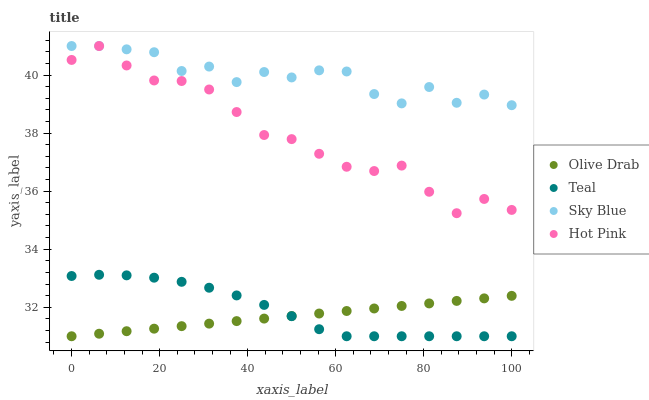Does Olive Drab have the minimum area under the curve?
Answer yes or no. Yes. Does Sky Blue have the maximum area under the curve?
Answer yes or no. Yes. Does Hot Pink have the minimum area under the curve?
Answer yes or no. No. Does Hot Pink have the maximum area under the curve?
Answer yes or no. No. Is Olive Drab the smoothest?
Answer yes or no. Yes. Is Sky Blue the roughest?
Answer yes or no. Yes. Is Hot Pink the smoothest?
Answer yes or no. No. Is Hot Pink the roughest?
Answer yes or no. No. Does Teal have the lowest value?
Answer yes or no. Yes. Does Hot Pink have the lowest value?
Answer yes or no. No. Does Hot Pink have the highest value?
Answer yes or no. Yes. Does Teal have the highest value?
Answer yes or no. No. Is Teal less than Sky Blue?
Answer yes or no. Yes. Is Sky Blue greater than Teal?
Answer yes or no. Yes. Does Sky Blue intersect Hot Pink?
Answer yes or no. Yes. Is Sky Blue less than Hot Pink?
Answer yes or no. No. Is Sky Blue greater than Hot Pink?
Answer yes or no. No. Does Teal intersect Sky Blue?
Answer yes or no. No. 